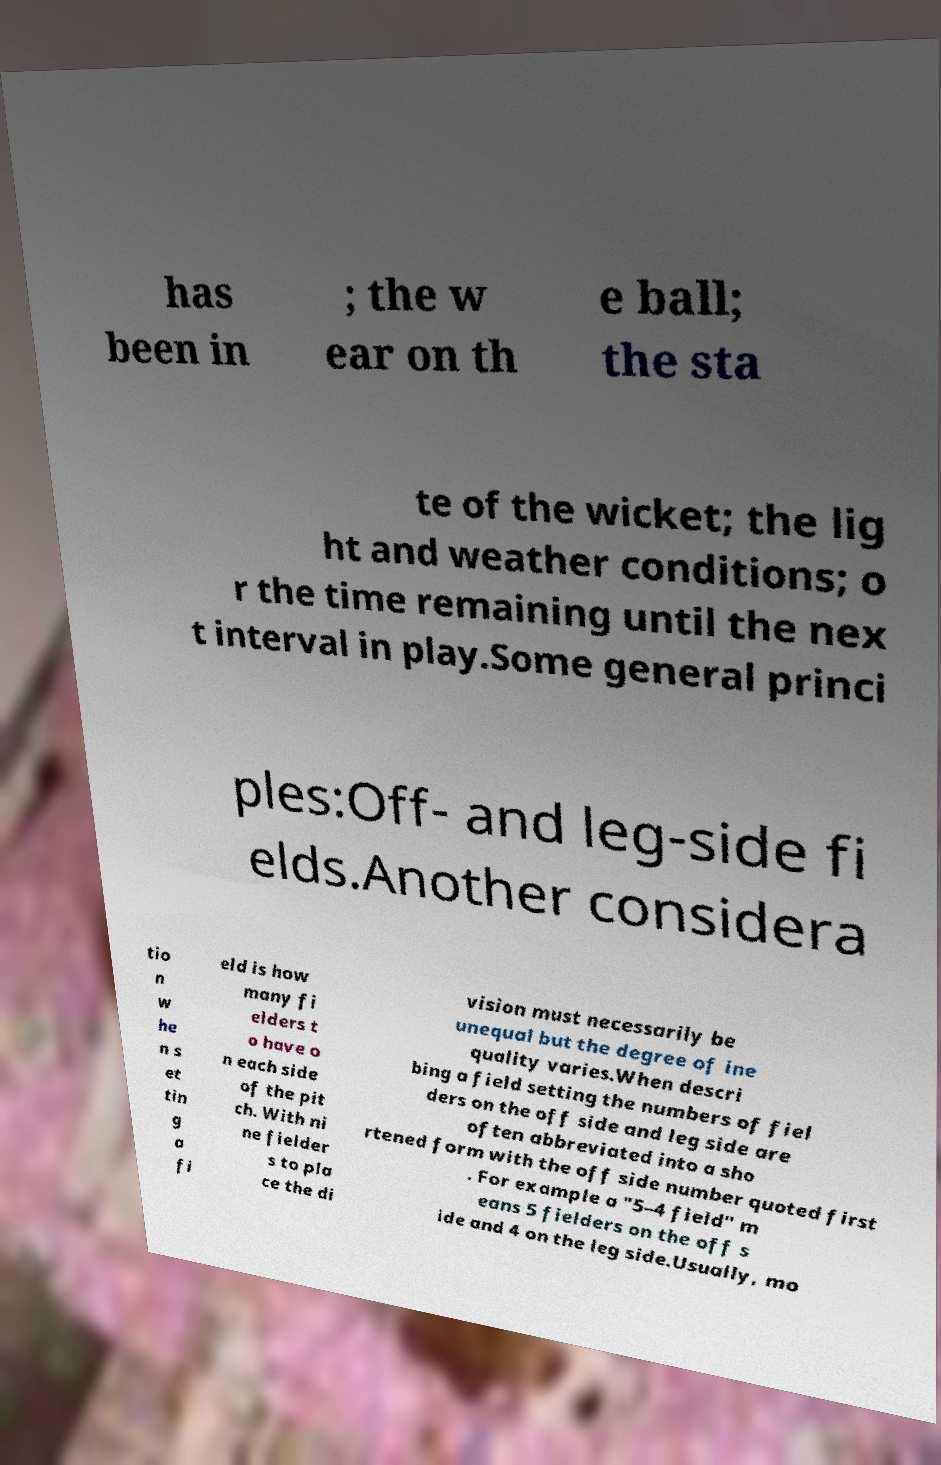Can you read and provide the text displayed in the image?This photo seems to have some interesting text. Can you extract and type it out for me? has been in ; the w ear on th e ball; the sta te of the wicket; the lig ht and weather conditions; o r the time remaining until the nex t interval in play.Some general princi ples:Off- and leg-side fi elds.Another considera tio n w he n s et tin g a fi eld is how many fi elders t o have o n each side of the pit ch. With ni ne fielder s to pla ce the di vision must necessarily be unequal but the degree of ine quality varies.When descri bing a field setting the numbers of fiel ders on the off side and leg side are often abbreviated into a sho rtened form with the off side number quoted first . For example a "5–4 field" m eans 5 fielders on the off s ide and 4 on the leg side.Usually, mo 